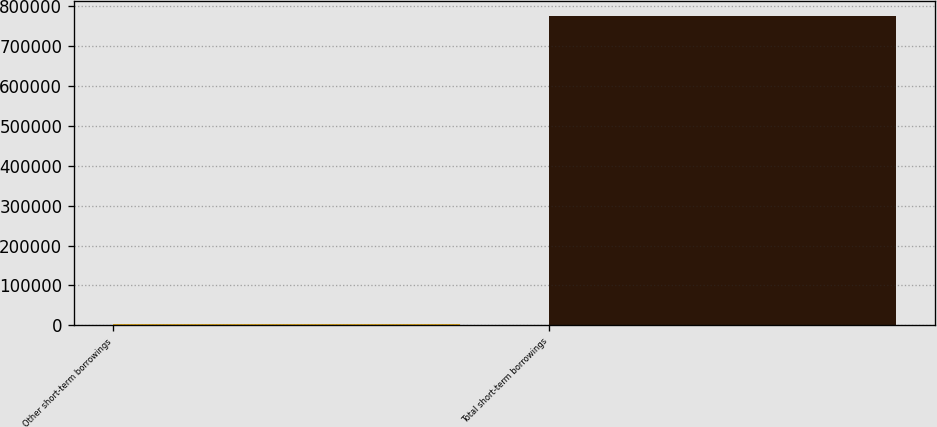<chart> <loc_0><loc_0><loc_500><loc_500><bar_chart><fcel>Other short-term borrowings<fcel>Total short-term borrowings<nl><fcel>1900<fcel>774900<nl></chart> 